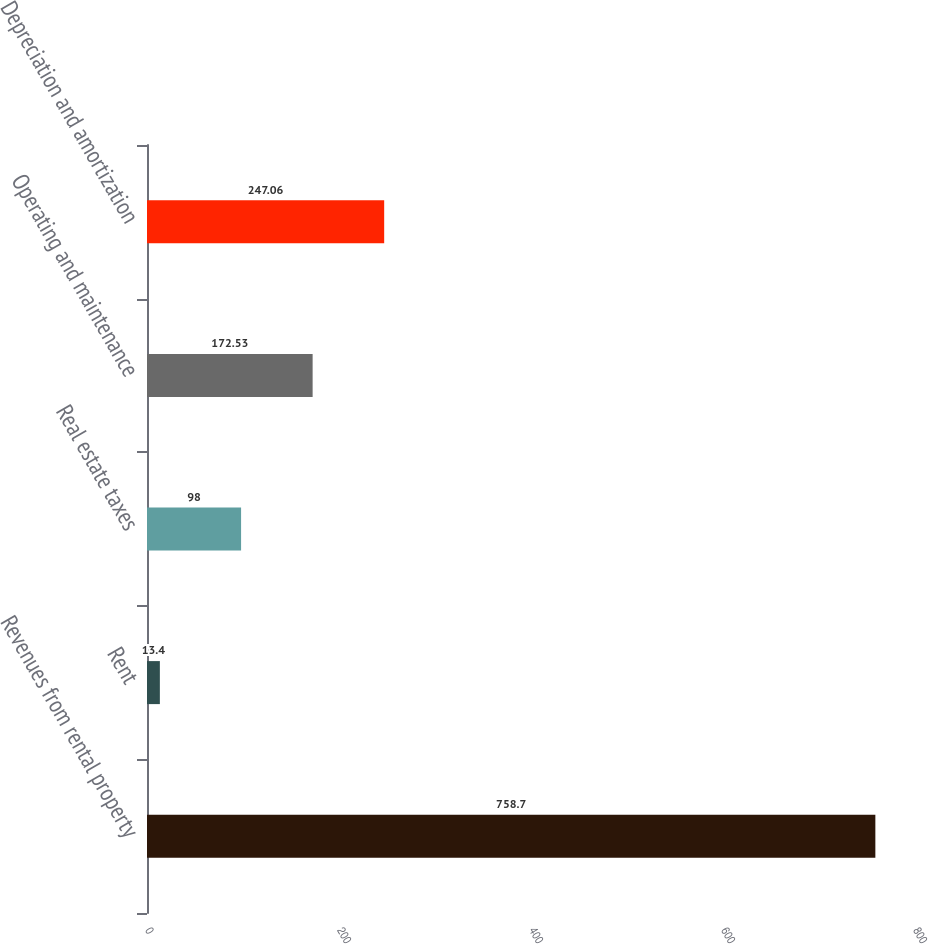Convert chart. <chart><loc_0><loc_0><loc_500><loc_500><bar_chart><fcel>Revenues from rental property<fcel>Rent<fcel>Real estate taxes<fcel>Operating and maintenance<fcel>Depreciation and amortization<nl><fcel>758.7<fcel>13.4<fcel>98<fcel>172.53<fcel>247.06<nl></chart> 